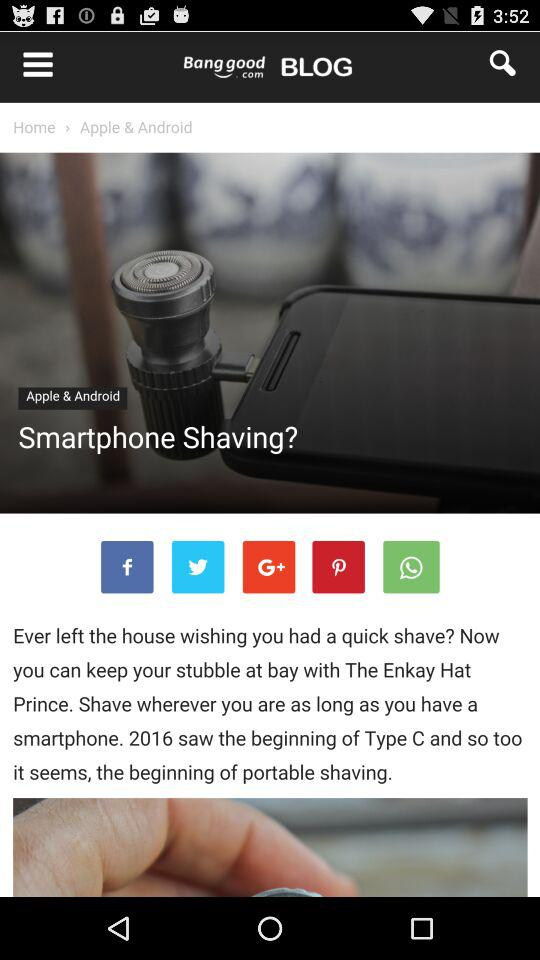What is the selected item for the search? The selected item is "cat bed". 